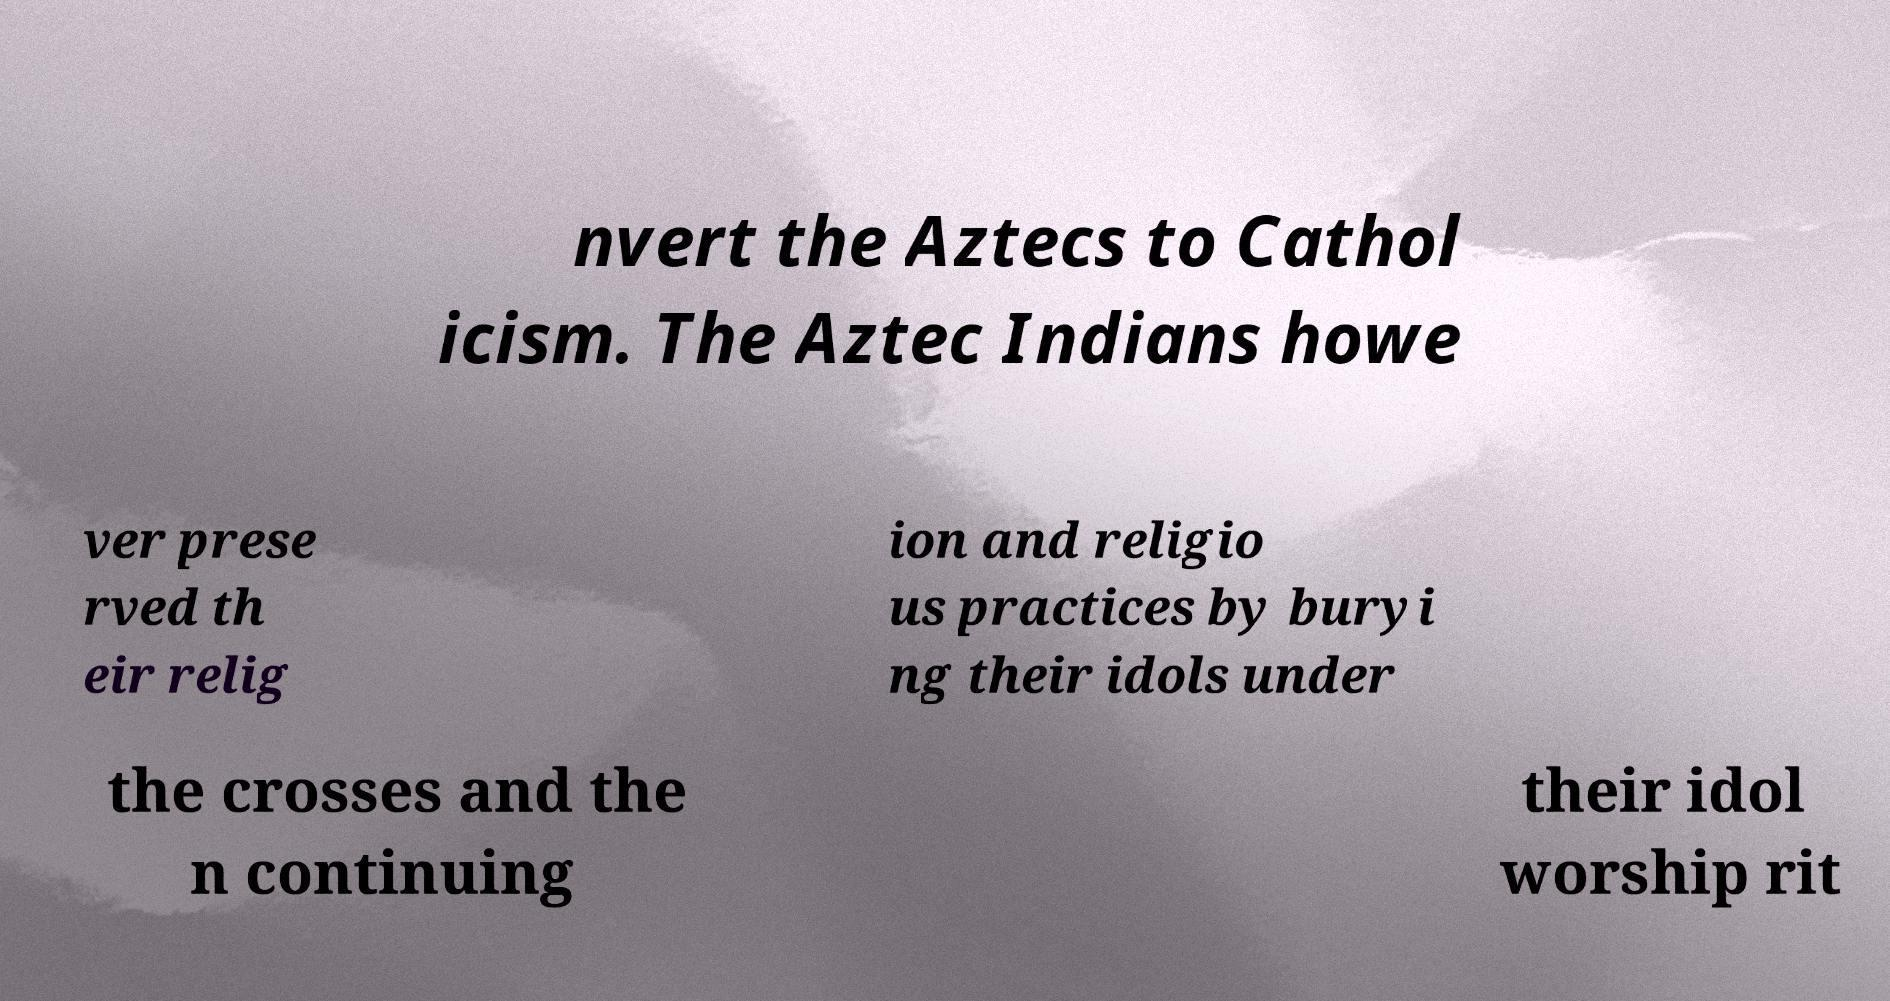Can you read and provide the text displayed in the image?This photo seems to have some interesting text. Can you extract and type it out for me? nvert the Aztecs to Cathol icism. The Aztec Indians howe ver prese rved th eir relig ion and religio us practices by buryi ng their idols under the crosses and the n continuing their idol worship rit 